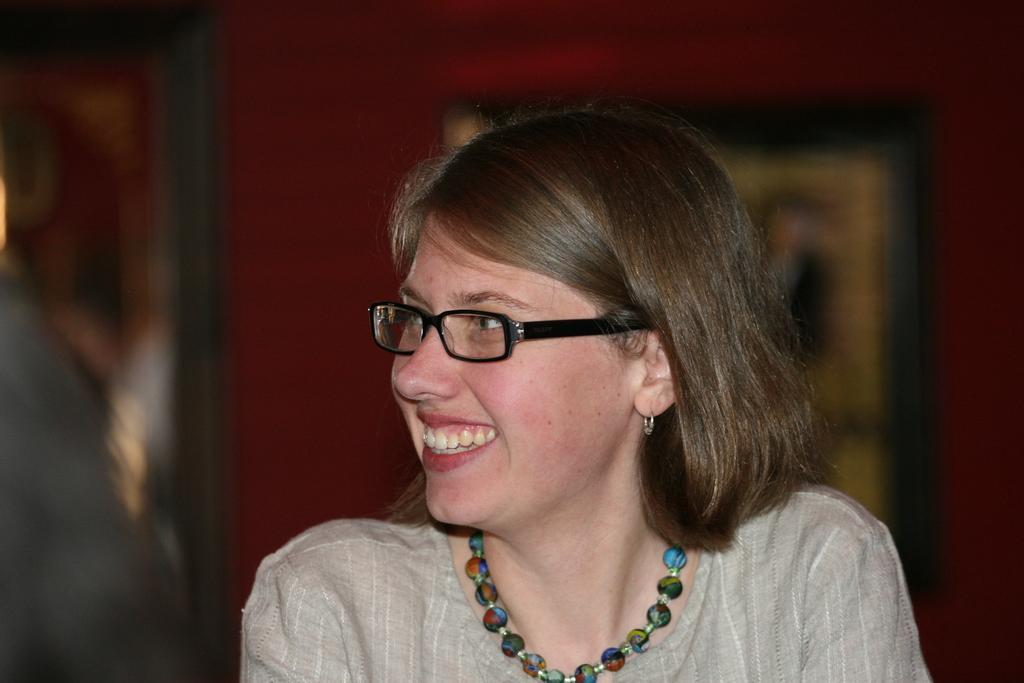In one or two sentences, can you explain what this image depicts? There is one women present at the bottom of this image and we can see a wall in the background. 